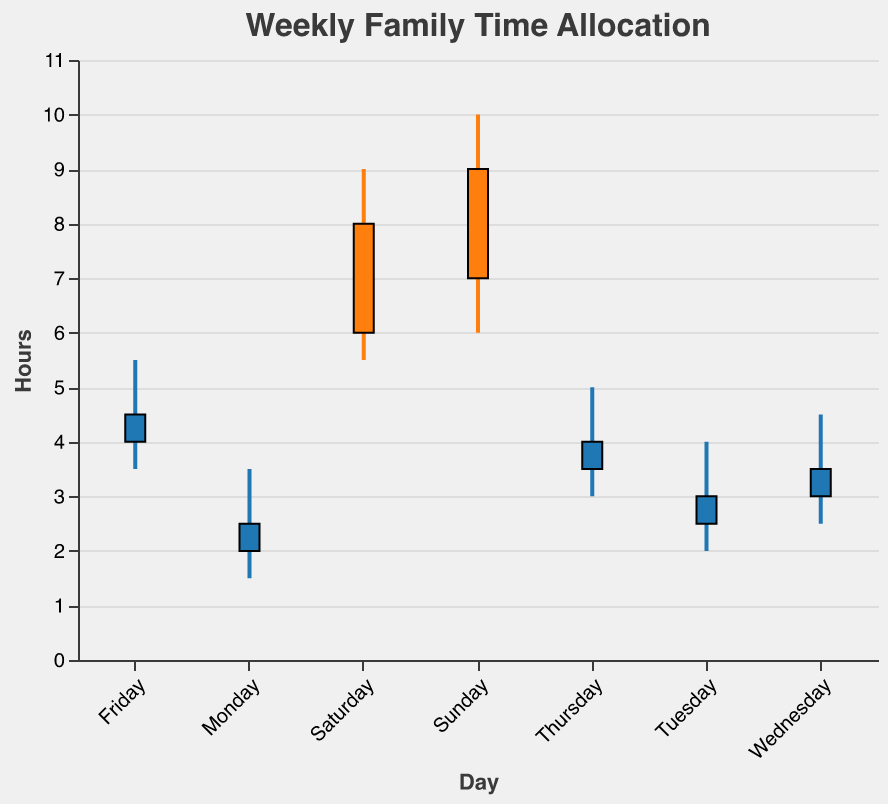Which day has the highest amount of family time allocated? Sunday's "High" value is 10, which is the highest "High" value in the data.
Answer: Sunday How does the family time allocated on weekdays compare to weekends? The "High" values for weekdays (Monday to Friday) range from 3.5 to 5.5, while the weekend days (Saturday and Sunday) have "High" values of 9 and 10. This indicates weekends have significantly more family time.
Answer: Weekends have more family time Which day shows the smallest difference between the "High" and "Low" values? Monday's "High" is 3.5 and "Low" is 1.5, giving a difference of 2. Comparatively, other days have differences of 2.0 (Tuesday), 2.0 (Wednesday), 2.0 (Thursday), 2.0 (Friday), 3.5 (Saturday), and 4.0 (Sunday).
Answer: Monday What is the median value of the "Open" times for the whole week? The "Open" times are [2, 2.5, 3, 3.5, 4, 6, 7]. The median is the middle value, which is 3.5.
Answer: 3.5 Which day marks the highest amount of increase in family time from "Open" to "Close"? Saturday has an "Open" value of 6 and a "Close" value of 8, indicating an increase of 2 hours, which is the highest compared to other days.
Answer: Saturday How many hours of family time are allocated on Tuesday according to the "Close" value? The "Close" value for Tuesday is 3.0 hours.
Answer: 3 Identify the day with the lowest family time allocation. What is its "Low" value? Monday has the lowest "Low" value, which is 1.5.
Answer: 1.5 Compare the "Open" values for the weekend days. Which day has the higher "Open" value, Saturday or Sunday? Sunday has an "Open" value of 7, higher than Saturday's "Open" value of 6.
Answer: Sunday What is the range of family time on Friday, and how is it calculated? The range is calculated as the difference between the "High" and "Low" values. For Friday, it is 5.5 - 3.5 = 2.
Answer: 2 What is the average "Close" value for the entire week? Summing all "Close" values: 2.5 + 3 + 3.5 + 4 + 4.5 + 8 + 9 = 34. Dividing by 7 days, the average = 34 / 7 ≈ 4.86.
Answer: 4.86 